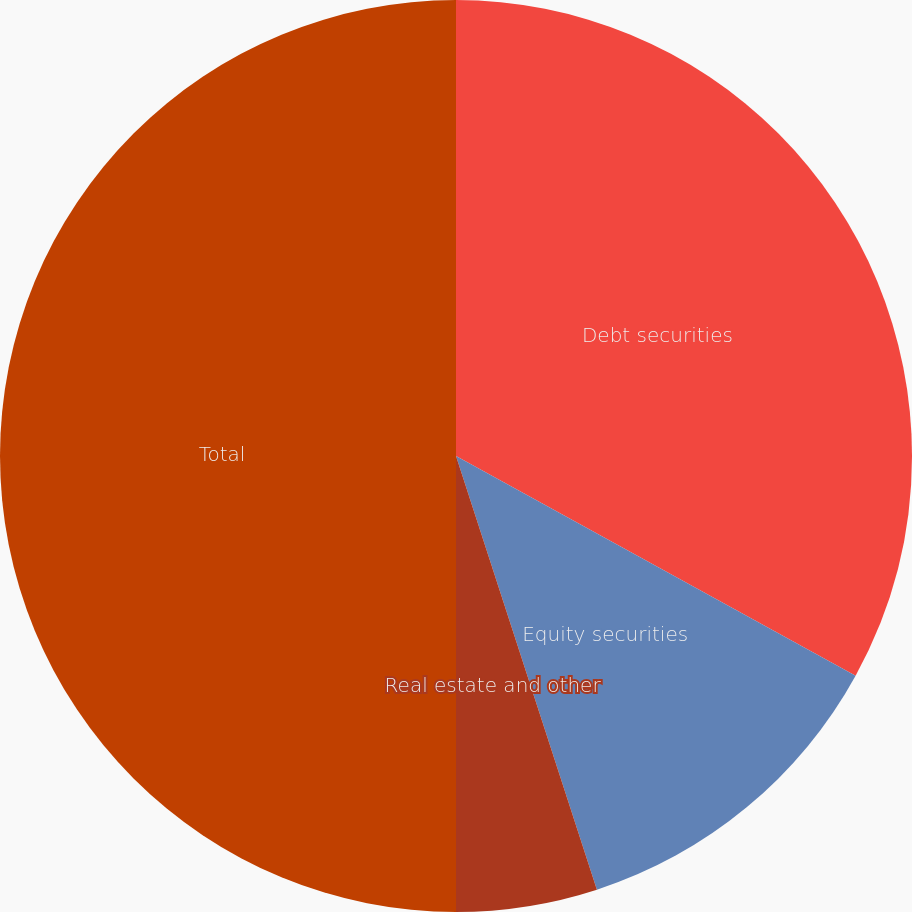Convert chart to OTSL. <chart><loc_0><loc_0><loc_500><loc_500><pie_chart><fcel>Debt securities<fcel>Equity securities<fcel>Real estate and other<fcel>Total<nl><fcel>33.0%<fcel>12.0%<fcel>5.0%<fcel>50.0%<nl></chart> 